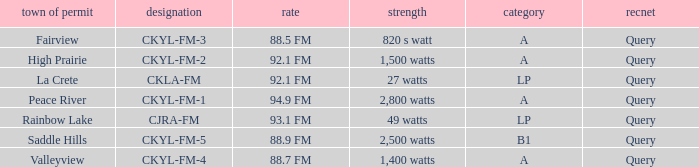What is the city of license that has a 1,400 watts power Valleyview. 